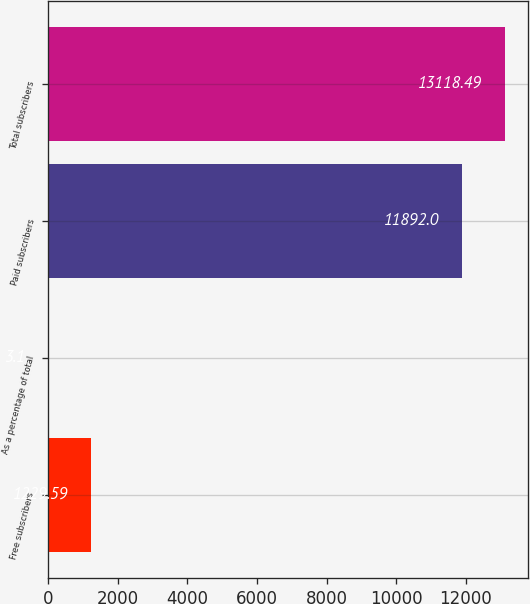Convert chart. <chart><loc_0><loc_0><loc_500><loc_500><bar_chart><fcel>Free subscribers<fcel>As a percentage of total<fcel>Paid subscribers<fcel>Total subscribers<nl><fcel>1229.59<fcel>3.1<fcel>11892<fcel>13118.5<nl></chart> 